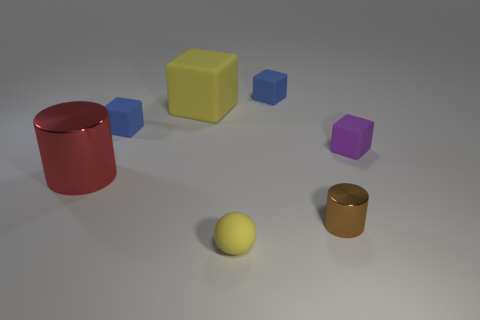Add 1 tiny things. How many objects exist? 8 Subtract all cubes. How many objects are left? 3 Subtract 0 green cubes. How many objects are left? 7 Subtract all large red shiny cylinders. Subtract all small purple cubes. How many objects are left? 5 Add 3 small yellow matte objects. How many small yellow matte objects are left? 4 Add 5 purple cubes. How many purple cubes exist? 6 